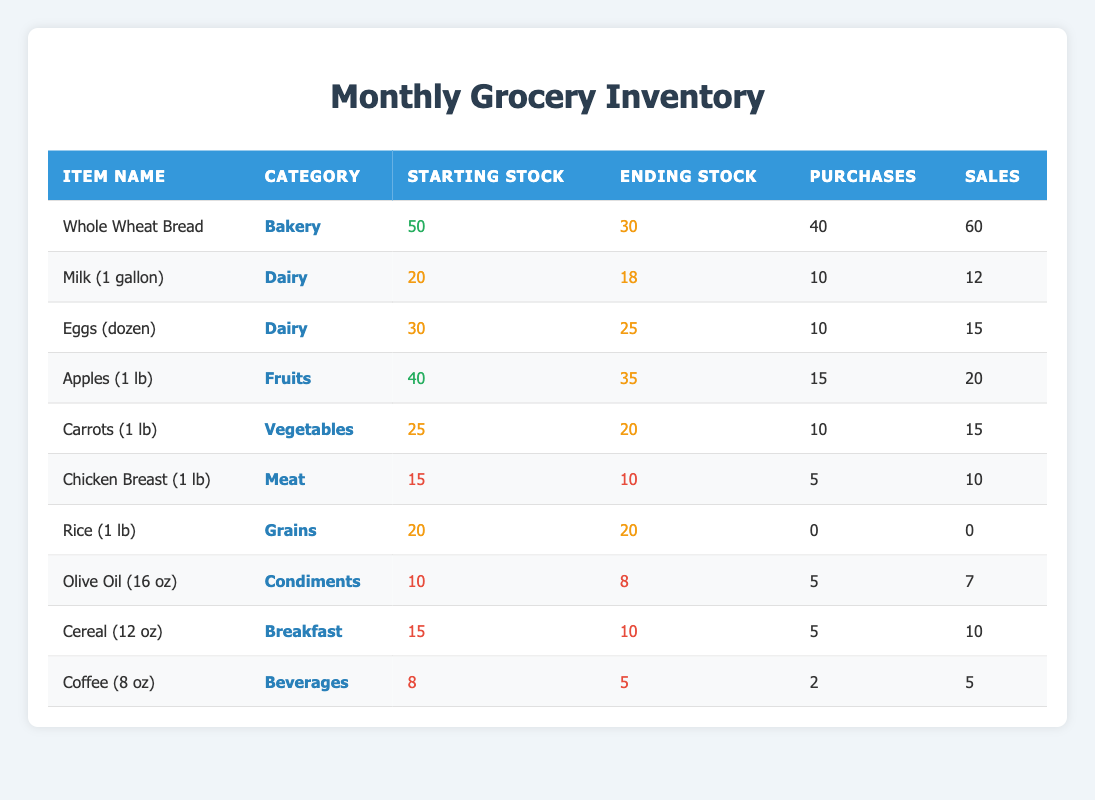What was the starting stock level of Whole Wheat Bread? The starting stock level is listed directly in the table for Whole Wheat Bread under the "Starting Stock" column. Looking at that row, the value is 50.
Answer: 50 How many units of Eggs (dozen) were sold in January? The number of units sold can be found directly in the table in the row for Eggs (dozen) under the "Sales" column. The value is 15.
Answer: 15 Which item had the highest starting stock level? To determine which item had the highest starting stock level, I can compare the "Starting Stock" values in each row. Whole Wheat Bread has the highest value of 50.
Answer: Whole Wheat Bread What was the total number of purchases of Dairy items? To find the total purchases of Dairy items, I need to look for all items in the Dairy category and sum their "Purchases" values. Milk has 10 and Eggs have 10; the total is 10 + 10 = 20.
Answer: 20 Did any item have the same ending stock level as its starting stock level? I need to check each row for items where the "Ending Stock" equals the "Starting Stock." Looking at the table, Rice (1 lb) has an ending stock of 20, which is the same as its starting stock of 20.
Answer: Yes How many more items were sold compared to purchases for Chicken Breast (1 lb)? To find out how many more items were sold compared to purchases, I subtract the purchases from the sales for Chicken Breast. It sold 10 and had 5 purchases, therefore 10 - 5 = 5 more sold than purchased.
Answer: 5 What is the average starting stock level of fruits in January? The table shows only one fruit item, which is Apples (1 lb) with a starting stock of 40. Since there's only one item, the average is the same as that item's stock.
Answer: 40 Which item experienced the largest decrease in stock level from the start to the end of January? By comparing the "Starting Stock" and "Ending Stock" levels for each item, I can calculate the decrease. Whole Wheat Bread decreased from 50 to 30, which is a decrease of 20. Eggs decreased from 30 to 25, which is 5. The largest decrease is for Whole Wheat Bread.
Answer: Whole Wheat Bread How many items are categorized as Dairy? I count the number of distinct items in the "Dairy" category, which includes Milk (1 gallon) and Eggs (dozen). Thus, there are 2 Dairy items listed in the table.
Answer: 2 